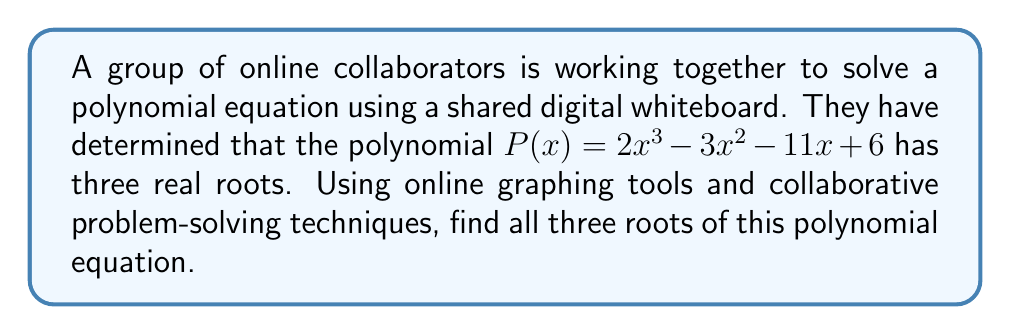Teach me how to tackle this problem. To solve this problem collaboratively, we can follow these steps:

1. Use an online graphing calculator to plot the function $y = 2x^3 - 3x^2 - 11x + 6$.

2. From the graph, we can visually identify that the polynomial crosses the x-axis at three points, confirming that there are three real roots.

3. To find the exact roots, we can use the rational root theorem. The possible rational roots are the factors of the constant term (6) divided by the factors of the leading coefficient (2):
   $\pm 1, \pm 2, \pm 3, \pm 6, \pm \frac{1}{2}, \pm 1, \pm \frac{3}{2}, \pm 3$

4. Test these potential roots using synthetic division or by evaluating $P(x)$ at each value.

5. We find that $x = -2$ is a root, as $P(-2) = 0$:
   $2(-2)^3 - 3(-2)^2 - 11(-2) + 6 = -16 - 12 + 22 + 6 = 0$

6. Divide the polynomial by $(x + 2)$ to get the quadratic factor:
   $2x^3 - 3x^2 - 11x + 6 = (x + 2)(2x^2 - 7x - 3)$

7. Use the quadratic formula to solve $2x^2 - 7x - 3 = 0$:
   $x = \frac{7 \pm \sqrt{49 + 24}}{4} = \frac{7 \pm \sqrt{73}}{4}$

8. Simplify to get the other two roots:
   $x = \frac{7 + \sqrt{73}}{4}$ and $x = \frac{7 - \sqrt{73}}{4}$

Through online collaboration, the group can verify each step and cross-check results to ensure accuracy.
Answer: The three roots of the polynomial $P(x) = 2x^3 - 3x^2 - 11x + 6$ are:

$x_1 = -2$
$x_2 = \frac{7 + \sqrt{73}}{4}$
$x_3 = \frac{7 - \sqrt{73}}{4}$ 